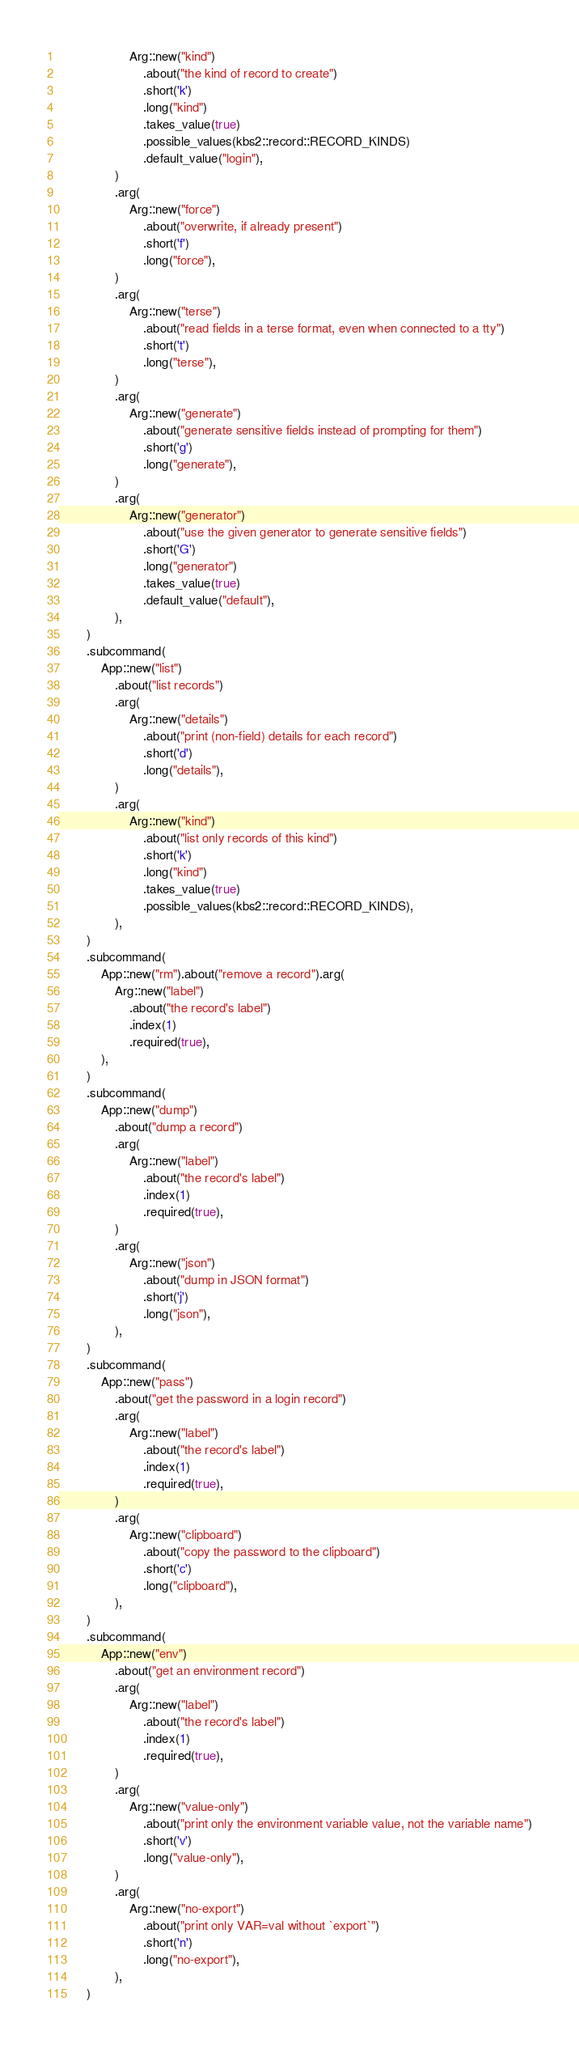Convert code to text. <code><loc_0><loc_0><loc_500><loc_500><_Rust_>                    Arg::new("kind")
                        .about("the kind of record to create")
                        .short('k')
                        .long("kind")
                        .takes_value(true)
                        .possible_values(kbs2::record::RECORD_KINDS)
                        .default_value("login"),
                )
                .arg(
                    Arg::new("force")
                        .about("overwrite, if already present")
                        .short('f')
                        .long("force"),
                )
                .arg(
                    Arg::new("terse")
                        .about("read fields in a terse format, even when connected to a tty")
                        .short('t')
                        .long("terse"),
                )
                .arg(
                    Arg::new("generate")
                        .about("generate sensitive fields instead of prompting for them")
                        .short('g')
                        .long("generate"),
                )
                .arg(
                    Arg::new("generator")
                        .about("use the given generator to generate sensitive fields")
                        .short('G')
                        .long("generator")
                        .takes_value(true)
                        .default_value("default"),
                ),
        )
        .subcommand(
            App::new("list")
                .about("list records")
                .arg(
                    Arg::new("details")
                        .about("print (non-field) details for each record")
                        .short('d')
                        .long("details"),
                )
                .arg(
                    Arg::new("kind")
                        .about("list only records of this kind")
                        .short('k')
                        .long("kind")
                        .takes_value(true)
                        .possible_values(kbs2::record::RECORD_KINDS),
                ),
        )
        .subcommand(
            App::new("rm").about("remove a record").arg(
                Arg::new("label")
                    .about("the record's label")
                    .index(1)
                    .required(true),
            ),
        )
        .subcommand(
            App::new("dump")
                .about("dump a record")
                .arg(
                    Arg::new("label")
                        .about("the record's label")
                        .index(1)
                        .required(true),
                )
                .arg(
                    Arg::new("json")
                        .about("dump in JSON format")
                        .short('j')
                        .long("json"),
                ),
        )
        .subcommand(
            App::new("pass")
                .about("get the password in a login record")
                .arg(
                    Arg::new("label")
                        .about("the record's label")
                        .index(1)
                        .required(true),
                )
                .arg(
                    Arg::new("clipboard")
                        .about("copy the password to the clipboard")
                        .short('c')
                        .long("clipboard"),
                ),
        )
        .subcommand(
            App::new("env")
                .about("get an environment record")
                .arg(
                    Arg::new("label")
                        .about("the record's label")
                        .index(1)
                        .required(true),
                )
                .arg(
                    Arg::new("value-only")
                        .about("print only the environment variable value, not the variable name")
                        .short('v')
                        .long("value-only"),
                )
                .arg(
                    Arg::new("no-export")
                        .about("print only VAR=val without `export`")
                        .short('n')
                        .long("no-export"),
                ),
        )</code> 